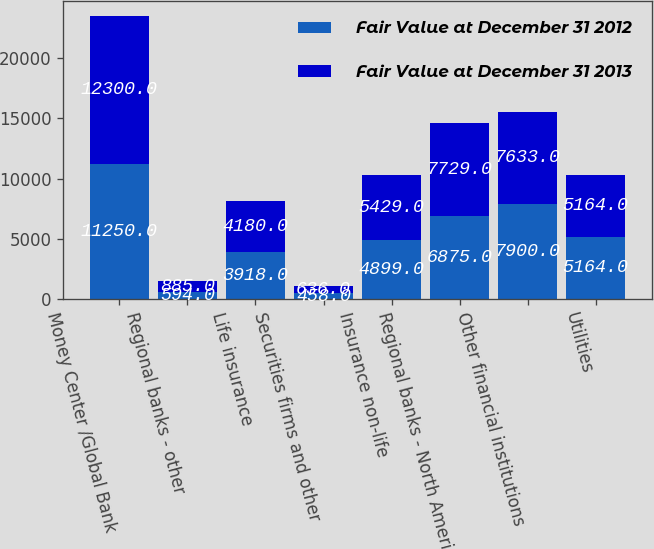Convert chart to OTSL. <chart><loc_0><loc_0><loc_500><loc_500><stacked_bar_chart><ecel><fcel>Money Center /Global Bank<fcel>Regional banks - other<fcel>Life insurance<fcel>Securities firms and other<fcel>Insurance non-life<fcel>Regional banks - North America<fcel>Other financial institutions<fcel>Utilities<nl><fcel>Fair Value at December 31 2012<fcel>11250<fcel>594<fcel>3918<fcel>458<fcel>4899<fcel>6875<fcel>7900<fcel>5164<nl><fcel>Fair Value at December 31 2013<fcel>12300<fcel>885<fcel>4180<fcel>636<fcel>5429<fcel>7729<fcel>7633<fcel>5164<nl></chart> 